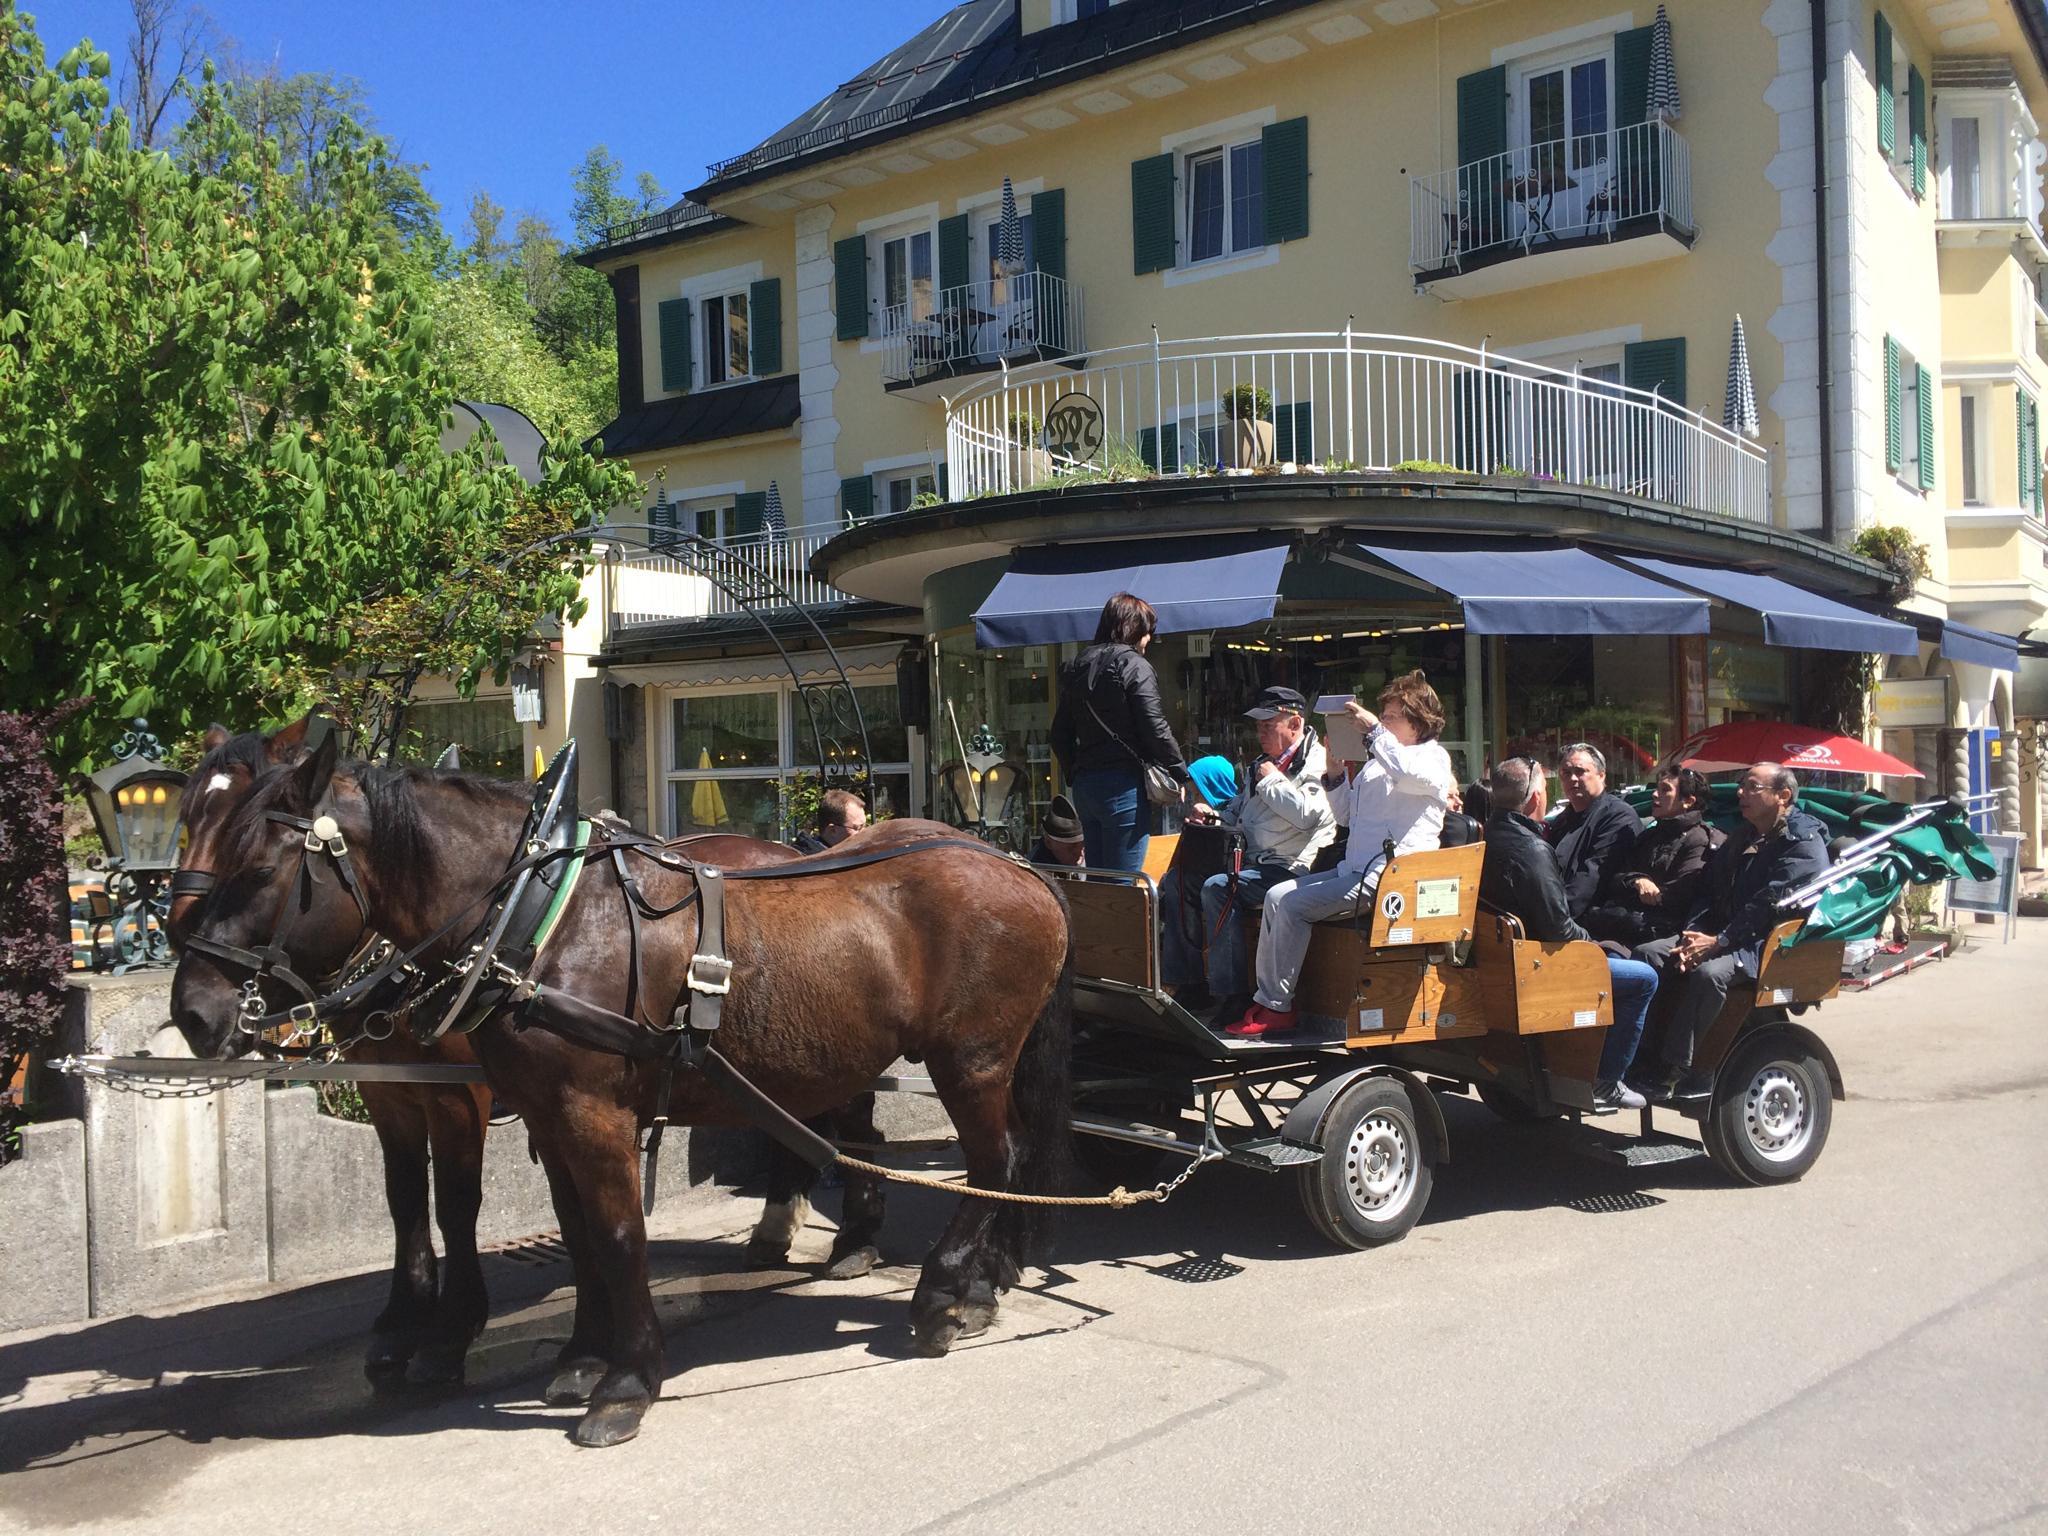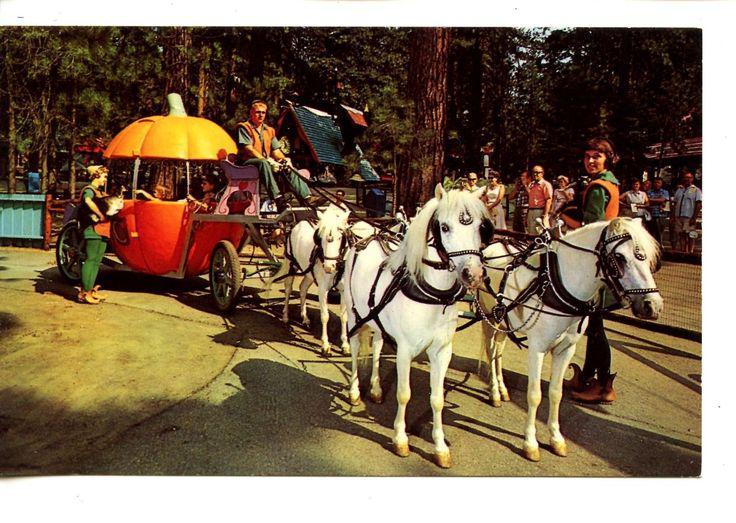The first image is the image on the left, the second image is the image on the right. Evaluate the accuracy of this statement regarding the images: "There are two white horses in the image on the left.". Is it true? Answer yes or no. No. 